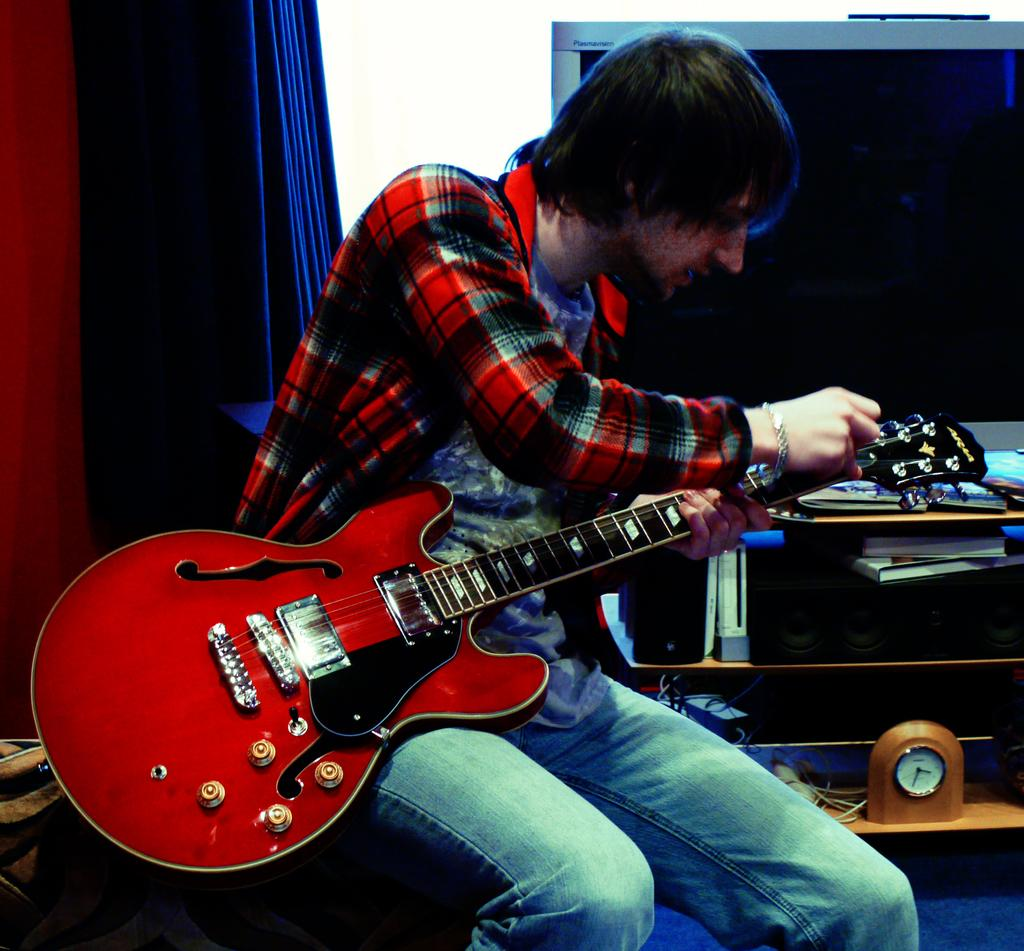What is the person in the image doing? The person is sitting and holding a guitar in his hands. What can be seen in the background of the image? There is a clock, a television screen, books, and a curtain in the background of the image. What might the person be doing with the guitar? The person might be playing the guitar or preparing to play it. What type of thread is being used to support the cast on the person's arm in the image? There is no cast or thread present in the image; the person is holding a guitar. 